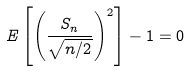Convert formula to latex. <formula><loc_0><loc_0><loc_500><loc_500>E \left [ \left ( \frac { S _ { n } } { \sqrt { n / 2 } } \right ) ^ { 2 } \right ] - 1 = 0</formula> 